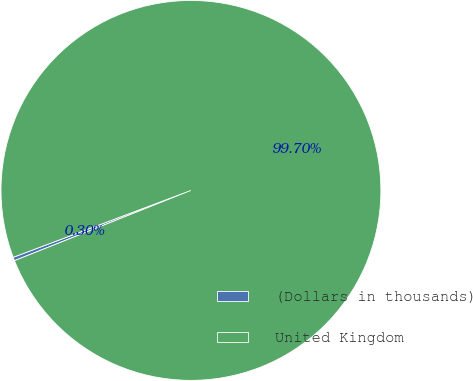<chart> <loc_0><loc_0><loc_500><loc_500><pie_chart><fcel>(Dollars in thousands)<fcel>United Kingdom<nl><fcel>0.3%<fcel>99.7%<nl></chart> 